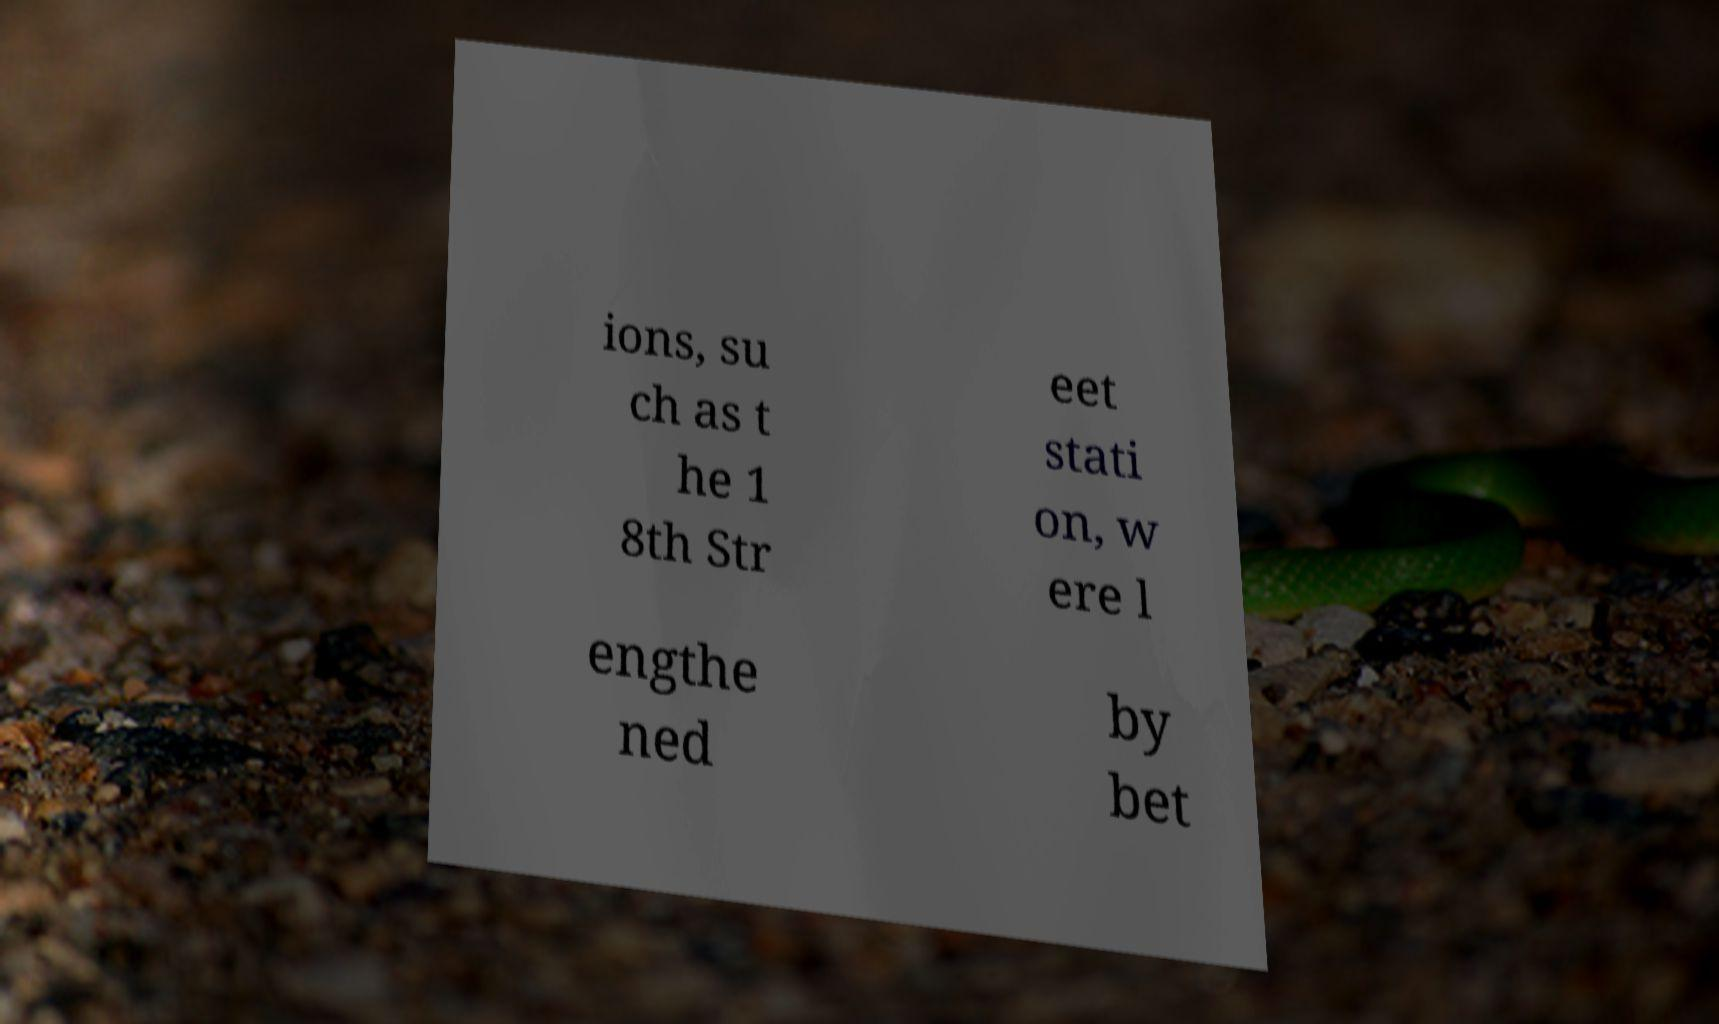Please identify and transcribe the text found in this image. ions, su ch as t he 1 8th Str eet stati on, w ere l engthe ned by bet 